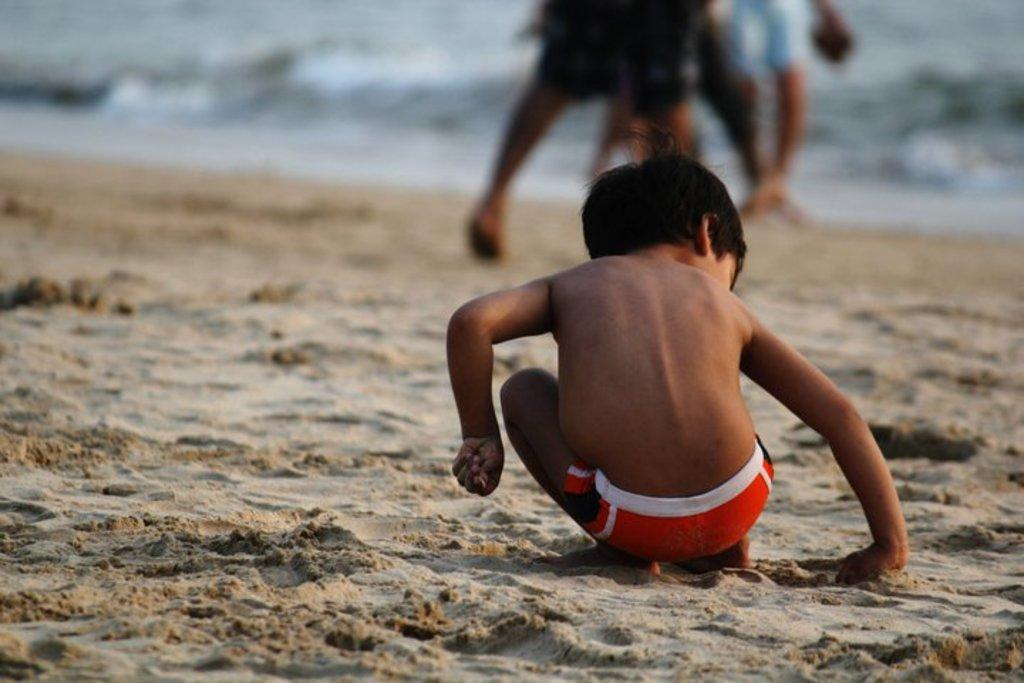What is the main subject of the image? The main subject of the image is a kid. Where is the kid sitting in the image? The kid is sitting on the sand. Can you describe the background of the image? The background of the image is blurred. Are there any other people visible in the image? Yes, there are legs of people in the background of the image. What type of shirt is the kid wearing in the image? The provided facts do not mention the type of shirt the kid is wearing, so we cannot determine that information from the image. 